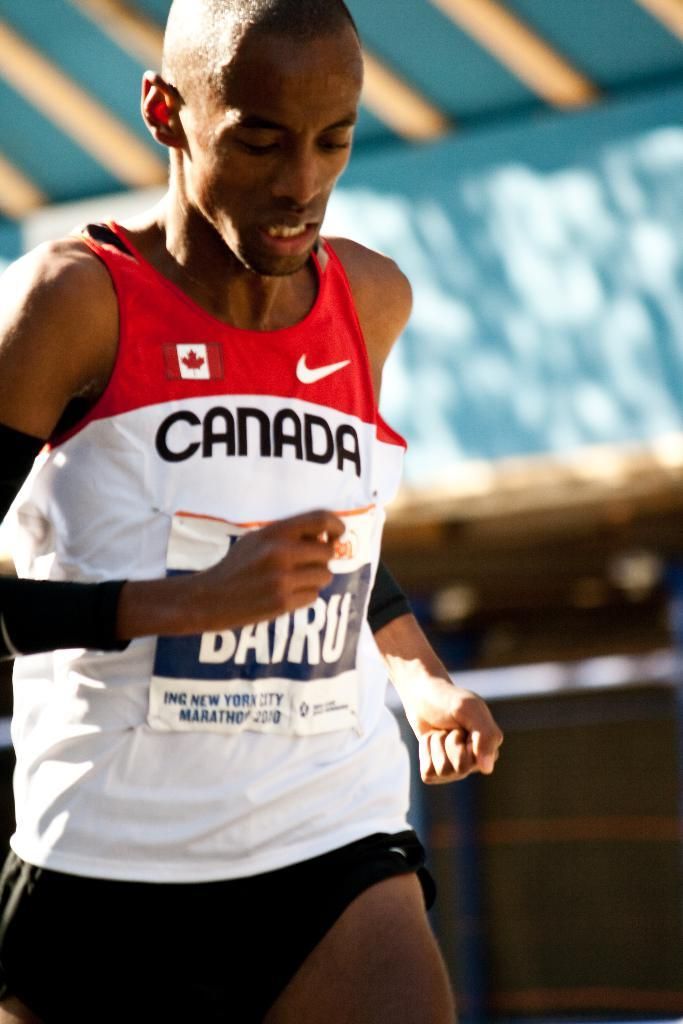<image>
Summarize the visual content of the image. A man is running track representing Canada and wearing a Nike shirt. 